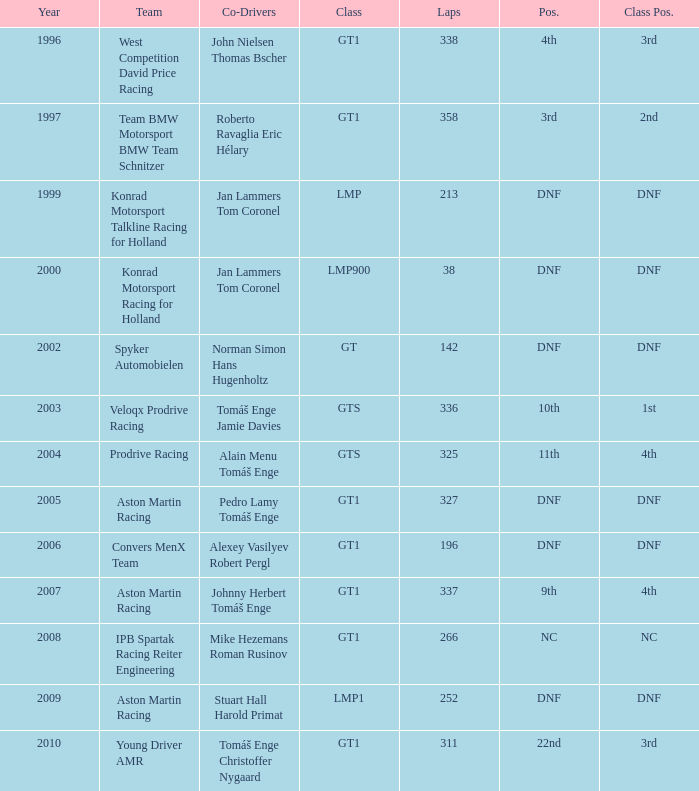Which team ended up 3rd in class, completing 337 laps before the year 2008? West Competition David Price Racing. 